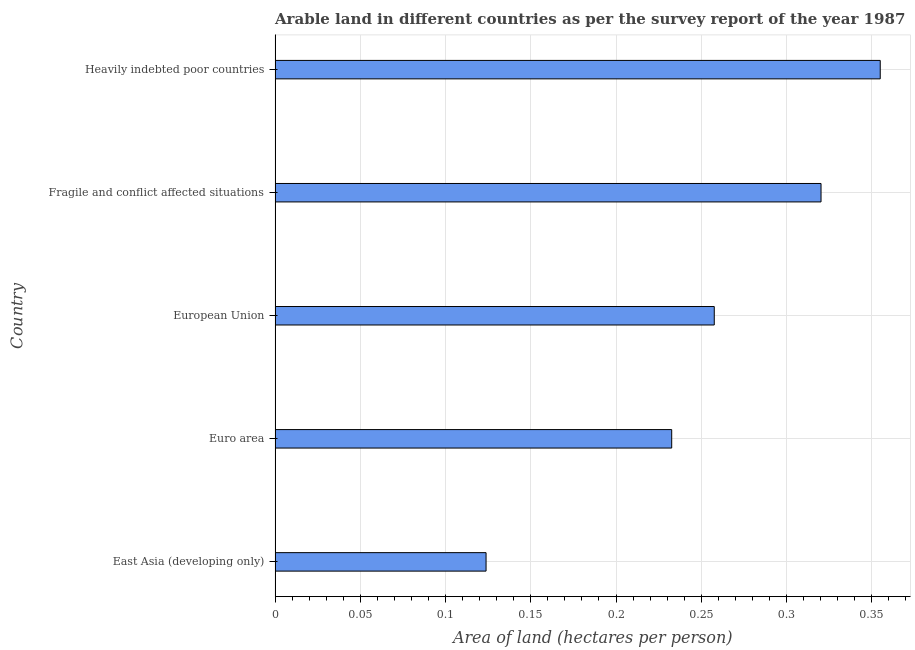Does the graph contain grids?
Keep it short and to the point. Yes. What is the title of the graph?
Keep it short and to the point. Arable land in different countries as per the survey report of the year 1987. What is the label or title of the X-axis?
Make the answer very short. Area of land (hectares per person). What is the area of arable land in East Asia (developing only)?
Offer a terse response. 0.12. Across all countries, what is the maximum area of arable land?
Your response must be concise. 0.35. Across all countries, what is the minimum area of arable land?
Make the answer very short. 0.12. In which country was the area of arable land maximum?
Provide a succinct answer. Heavily indebted poor countries. In which country was the area of arable land minimum?
Provide a succinct answer. East Asia (developing only). What is the sum of the area of arable land?
Your response must be concise. 1.29. What is the difference between the area of arable land in East Asia (developing only) and European Union?
Your answer should be compact. -0.13. What is the average area of arable land per country?
Your answer should be compact. 0.26. What is the median area of arable land?
Your answer should be very brief. 0.26. In how many countries, is the area of arable land greater than 0.24 hectares per person?
Give a very brief answer. 3. What is the ratio of the area of arable land in Euro area to that in European Union?
Your answer should be very brief. 0.9. What is the difference between the highest and the second highest area of arable land?
Your response must be concise. 0.04. Is the sum of the area of arable land in Euro area and Fragile and conflict affected situations greater than the maximum area of arable land across all countries?
Ensure brevity in your answer.  Yes. What is the difference between the highest and the lowest area of arable land?
Provide a short and direct response. 0.23. How many bars are there?
Offer a terse response. 5. How many countries are there in the graph?
Ensure brevity in your answer.  5. Are the values on the major ticks of X-axis written in scientific E-notation?
Your answer should be very brief. No. What is the Area of land (hectares per person) of East Asia (developing only)?
Offer a very short reply. 0.12. What is the Area of land (hectares per person) in Euro area?
Provide a short and direct response. 0.23. What is the Area of land (hectares per person) of European Union?
Offer a terse response. 0.26. What is the Area of land (hectares per person) in Fragile and conflict affected situations?
Keep it short and to the point. 0.32. What is the Area of land (hectares per person) of Heavily indebted poor countries?
Your answer should be compact. 0.35. What is the difference between the Area of land (hectares per person) in East Asia (developing only) and Euro area?
Offer a very short reply. -0.11. What is the difference between the Area of land (hectares per person) in East Asia (developing only) and European Union?
Provide a short and direct response. -0.13. What is the difference between the Area of land (hectares per person) in East Asia (developing only) and Fragile and conflict affected situations?
Offer a terse response. -0.2. What is the difference between the Area of land (hectares per person) in East Asia (developing only) and Heavily indebted poor countries?
Your answer should be very brief. -0.23. What is the difference between the Area of land (hectares per person) in Euro area and European Union?
Provide a succinct answer. -0.02. What is the difference between the Area of land (hectares per person) in Euro area and Fragile and conflict affected situations?
Make the answer very short. -0.09. What is the difference between the Area of land (hectares per person) in Euro area and Heavily indebted poor countries?
Make the answer very short. -0.12. What is the difference between the Area of land (hectares per person) in European Union and Fragile and conflict affected situations?
Your response must be concise. -0.06. What is the difference between the Area of land (hectares per person) in European Union and Heavily indebted poor countries?
Offer a terse response. -0.1. What is the difference between the Area of land (hectares per person) in Fragile and conflict affected situations and Heavily indebted poor countries?
Ensure brevity in your answer.  -0.03. What is the ratio of the Area of land (hectares per person) in East Asia (developing only) to that in Euro area?
Provide a short and direct response. 0.53. What is the ratio of the Area of land (hectares per person) in East Asia (developing only) to that in European Union?
Make the answer very short. 0.48. What is the ratio of the Area of land (hectares per person) in East Asia (developing only) to that in Fragile and conflict affected situations?
Offer a very short reply. 0.39. What is the ratio of the Area of land (hectares per person) in East Asia (developing only) to that in Heavily indebted poor countries?
Provide a succinct answer. 0.35. What is the ratio of the Area of land (hectares per person) in Euro area to that in European Union?
Offer a terse response. 0.9. What is the ratio of the Area of land (hectares per person) in Euro area to that in Fragile and conflict affected situations?
Give a very brief answer. 0.73. What is the ratio of the Area of land (hectares per person) in Euro area to that in Heavily indebted poor countries?
Provide a short and direct response. 0.66. What is the ratio of the Area of land (hectares per person) in European Union to that in Fragile and conflict affected situations?
Your answer should be compact. 0.8. What is the ratio of the Area of land (hectares per person) in European Union to that in Heavily indebted poor countries?
Your answer should be very brief. 0.73. What is the ratio of the Area of land (hectares per person) in Fragile and conflict affected situations to that in Heavily indebted poor countries?
Make the answer very short. 0.9. 